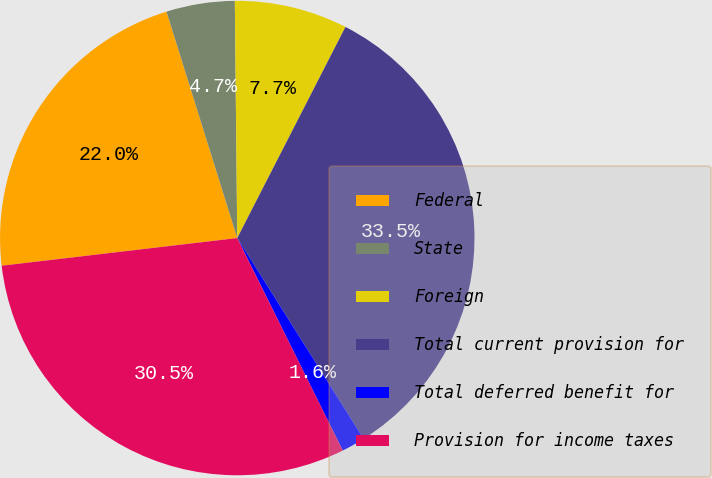<chart> <loc_0><loc_0><loc_500><loc_500><pie_chart><fcel>Federal<fcel>State<fcel>Foreign<fcel>Total current provision for<fcel>Total deferred benefit for<fcel>Provision for income taxes<nl><fcel>22.04%<fcel>4.66%<fcel>7.7%<fcel>33.52%<fcel>1.61%<fcel>30.47%<nl></chart> 